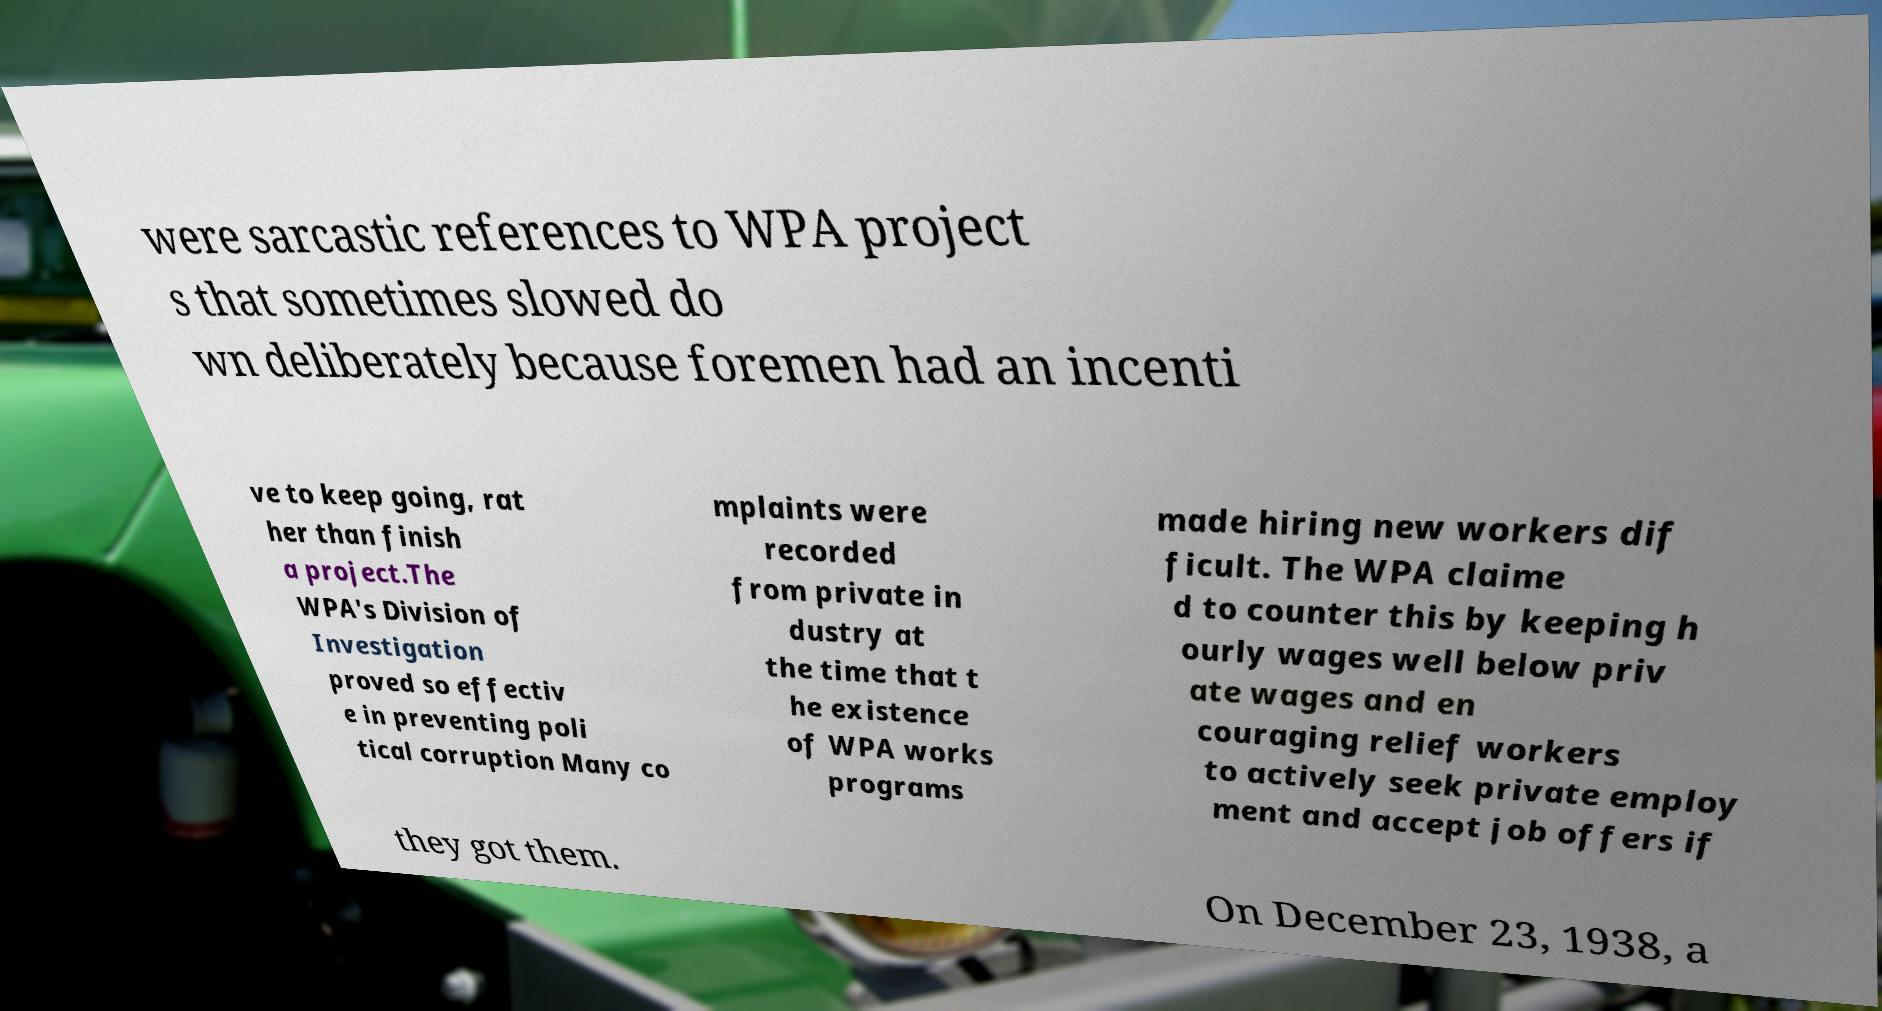Can you accurately transcribe the text from the provided image for me? were sarcastic references to WPA project s that sometimes slowed do wn deliberately because foremen had an incenti ve to keep going, rat her than finish a project.The WPA's Division of Investigation proved so effectiv e in preventing poli tical corruption Many co mplaints were recorded from private in dustry at the time that t he existence of WPA works programs made hiring new workers dif ficult. The WPA claime d to counter this by keeping h ourly wages well below priv ate wages and en couraging relief workers to actively seek private employ ment and accept job offers if they got them. On December 23, 1938, a 